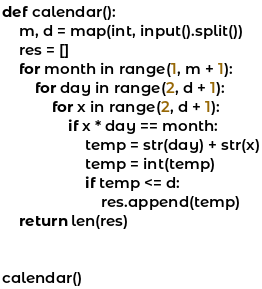Convert code to text. <code><loc_0><loc_0><loc_500><loc_500><_Python_>def calendar():
    m, d = map(int, input().split())
    res = []
    for month in range(1, m + 1):
        for day in range(2, d + 1):
            for x in range(2, d + 1):
                if x * day == month:
                    temp = str(day) + str(x)
                    temp = int(temp)
                    if temp <= d:
                        res.append(temp)
    return len(res)
 
 
calendar()</code> 